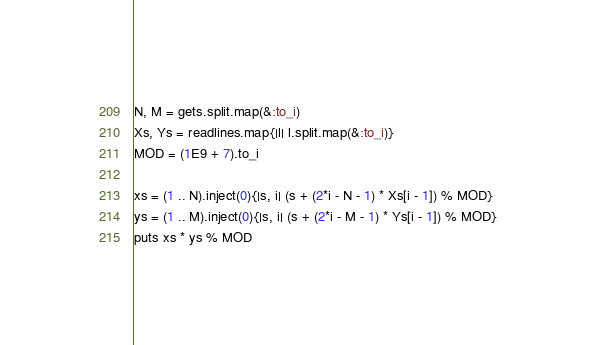Convert code to text. <code><loc_0><loc_0><loc_500><loc_500><_Ruby_>N, M = gets.split.map(&:to_i)
Xs, Ys = readlines.map{|l| l.split.map(&:to_i)}
MOD = (1E9 + 7).to_i

xs = (1 .. N).inject(0){|s, i| (s + (2*i - N - 1) * Xs[i - 1]) % MOD}
ys = (1 .. M).inject(0){|s, i| (s + (2*i - M - 1) * Ys[i - 1]) % MOD}
puts xs * ys % MOD</code> 